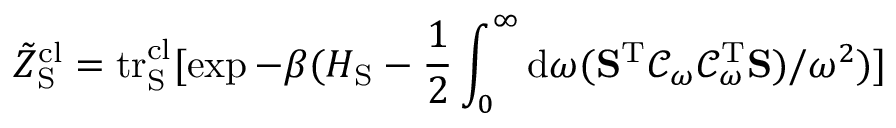Convert formula to latex. <formula><loc_0><loc_0><loc_500><loc_500>\tilde { Z } _ { S } ^ { c l } = t r _ { S } ^ { c l } [ \exp { - \beta ( H _ { S } - \frac { 1 } { 2 } \int _ { 0 } ^ { \infty } d \omega ( S ^ { T } \mathcal { C } _ { \omega } \mathcal { C } _ { \omega } ^ { T } S ) / \omega ^ { 2 } ) } ]</formula> 